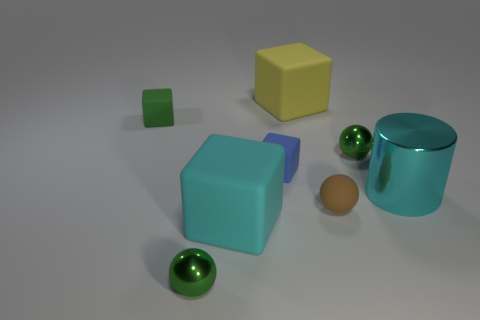What's the arrangement of objects in terms of depth from the perspective of the image? From the viewpoint of the image, the objects are arranged at varying depths. The small green cube appears closest to the viewer, followed by the yellow cube and the blue cube. At a further distance, you can see the three green spheres lined up, and finally, the cyan cylinder is positioned furthest from the viewer. 